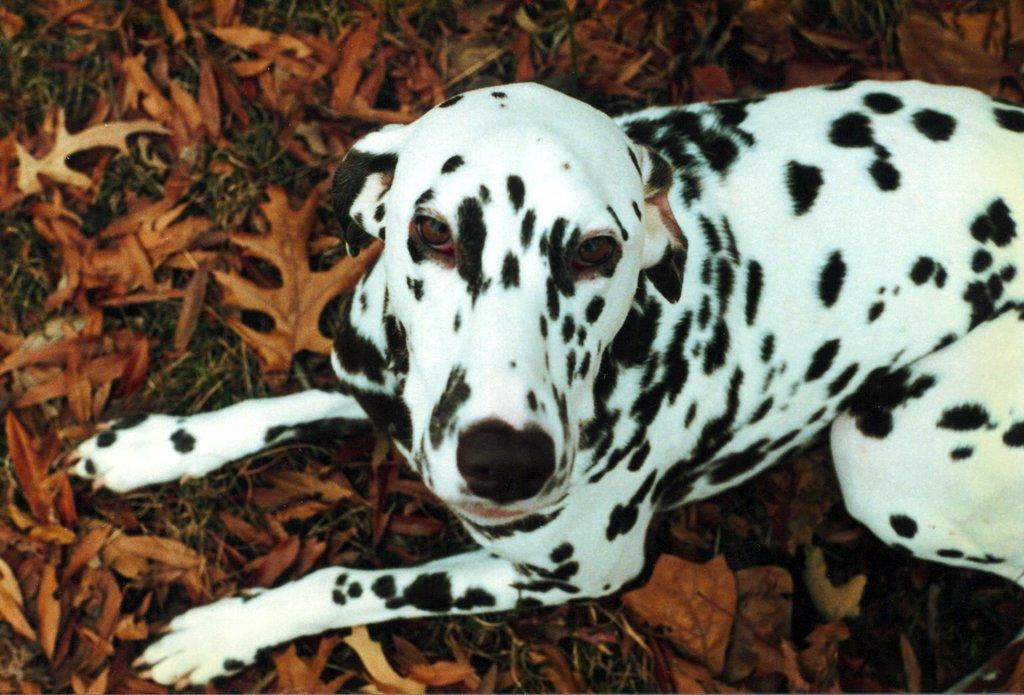What animal is present in the image? There is a dog in the image. What position is the dog in? The dog is sitting on the ground. What type of vegetation is visible on the ground in the image? There are leaves and grass on the ground in the image. Can you see the dog's self in the image? There is no indication of a dog's self in the image, as the concept of a self is not applicable to animals. What type of vein can be seen in the image? There are no veins visible in the image; it features a dog sitting on the ground with leaves and grass on the ground. 